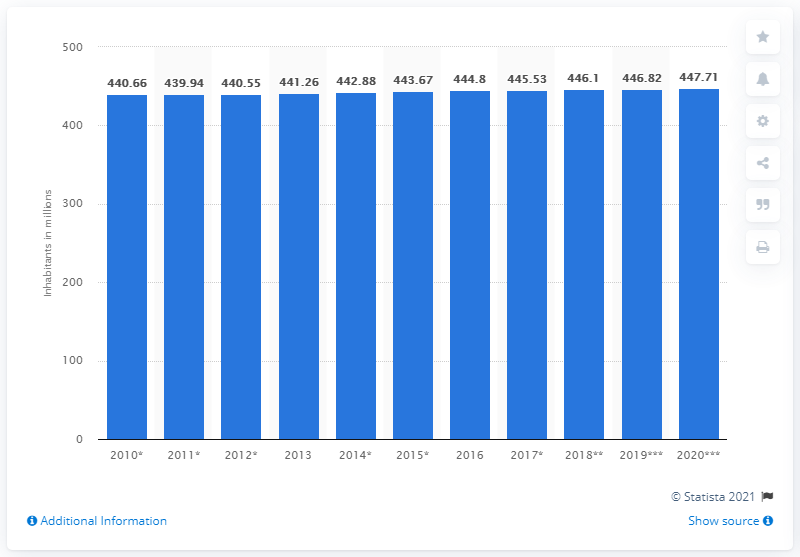Give some essential details in this illustration. At the beginning of 2020, the population of the European Union was approximately 447.71 million. 